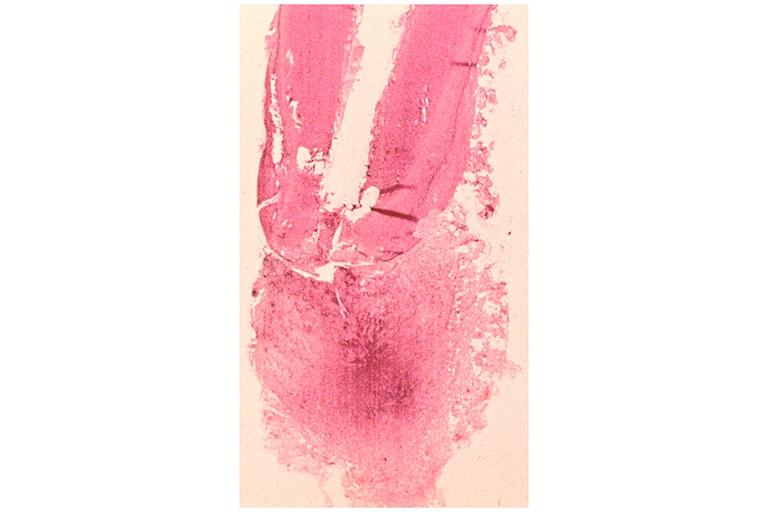s this close-up of cut surface infiltrates present?
Answer the question using a single word or phrase. No 